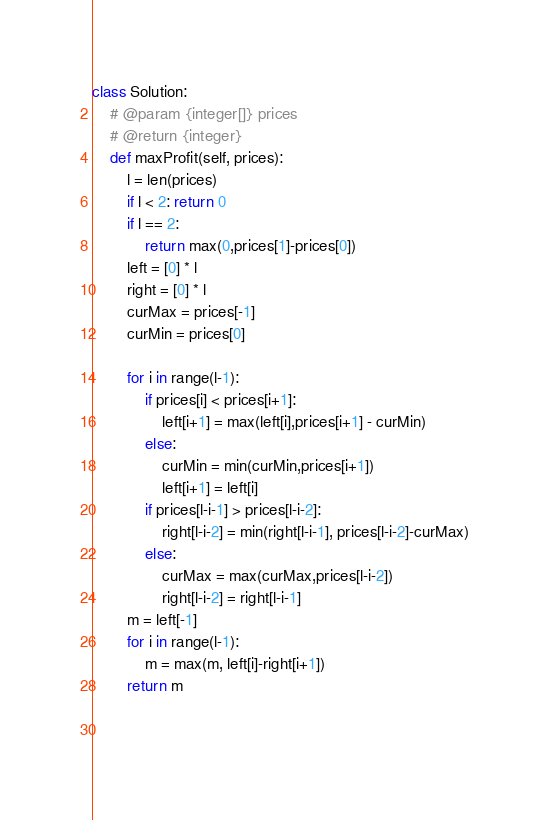Convert code to text. <code><loc_0><loc_0><loc_500><loc_500><_Python_>class Solution:    # @param {integer[]} prices    # @return {integer}    def maxProfit(self, prices):        l = len(prices)        if l < 2: return 0        if l == 2:            return max(0,prices[1]-prices[0])        left = [0] * l        right = [0] * l        curMax = prices[-1]        curMin = prices[0]                for i in range(l-1):            if prices[i] < prices[i+1]:                left[i+1] = max(left[i],prices[i+1] - curMin)            else:                curMin = min(curMin,prices[i+1])                left[i+1] = left[i]            if prices[l-i-1] > prices[l-i-2]:                right[l-i-2] = min(right[l-i-1], prices[l-i-2]-curMax)            else:                curMax = max(curMax,prices[l-i-2])                right[l-i-2] = right[l-i-1]        m = left[-1]        for i in range(l-1):            m = max(m, left[i]-right[i+1])        return m                </code> 